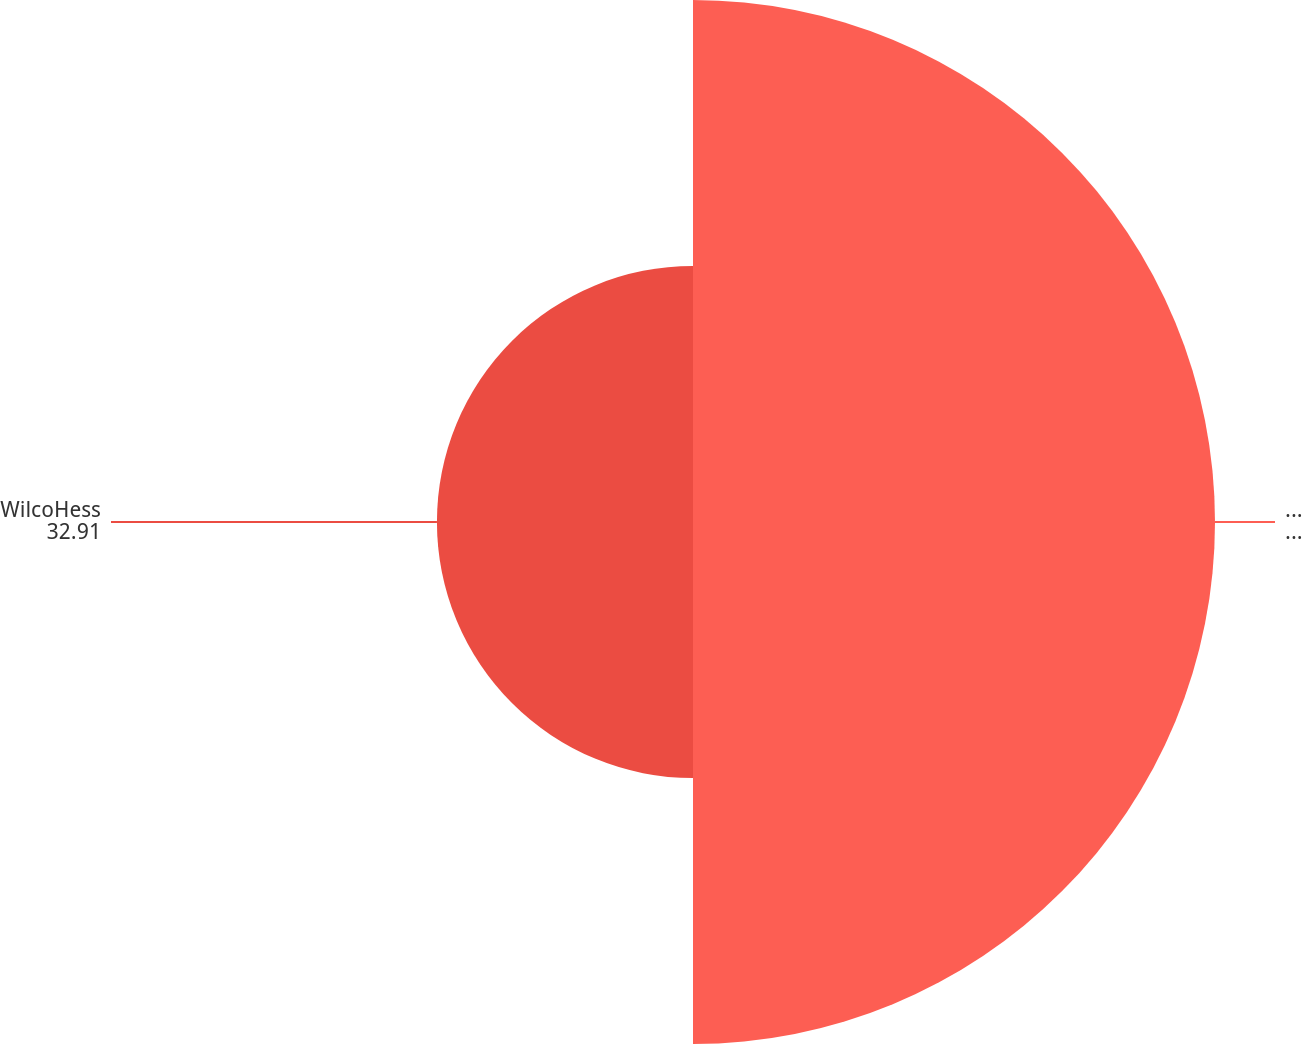<chart> <loc_0><loc_0><loc_500><loc_500><pie_chart><fcel>HOVENSA<fcel>WilcoHess<nl><fcel>67.09%<fcel>32.91%<nl></chart> 